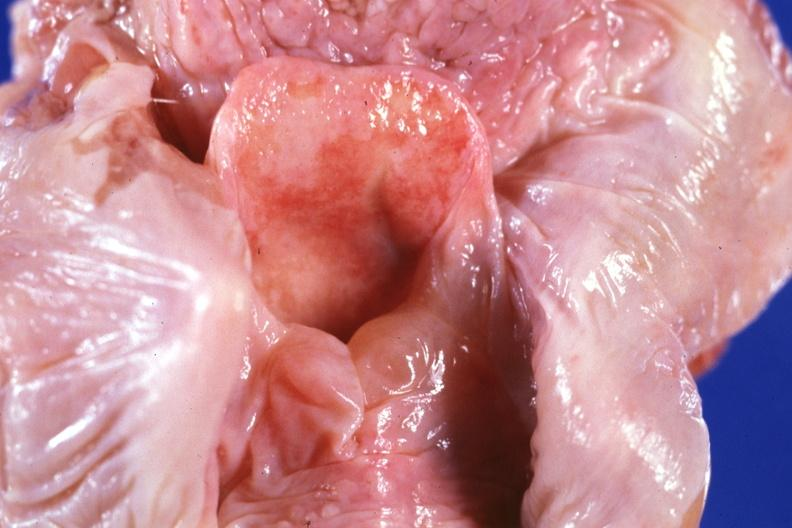what is unopened larynx seen from above edema in?
Answer the question using a single word or phrase. In hypopharynx 